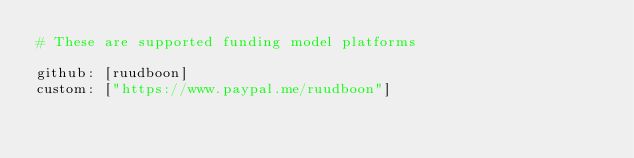Convert code to text. <code><loc_0><loc_0><loc_500><loc_500><_YAML_># These are supported funding model platforms

github: [ruudboon]
custom: ["https://www.paypal.me/ruudboon"]
</code> 